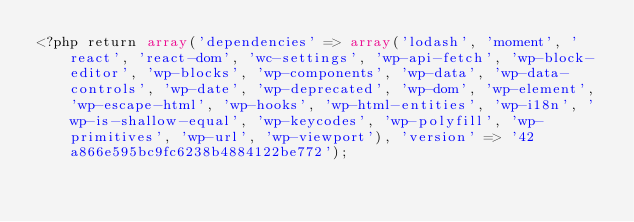<code> <loc_0><loc_0><loc_500><loc_500><_PHP_><?php return array('dependencies' => array('lodash', 'moment', 'react', 'react-dom', 'wc-settings', 'wp-api-fetch', 'wp-block-editor', 'wp-blocks', 'wp-components', 'wp-data', 'wp-data-controls', 'wp-date', 'wp-deprecated', 'wp-dom', 'wp-element', 'wp-escape-html', 'wp-hooks', 'wp-html-entities', 'wp-i18n', 'wp-is-shallow-equal', 'wp-keycodes', 'wp-polyfill', 'wp-primitives', 'wp-url', 'wp-viewport'), 'version' => '42a866e595bc9fc6238b4884122be772');</code> 